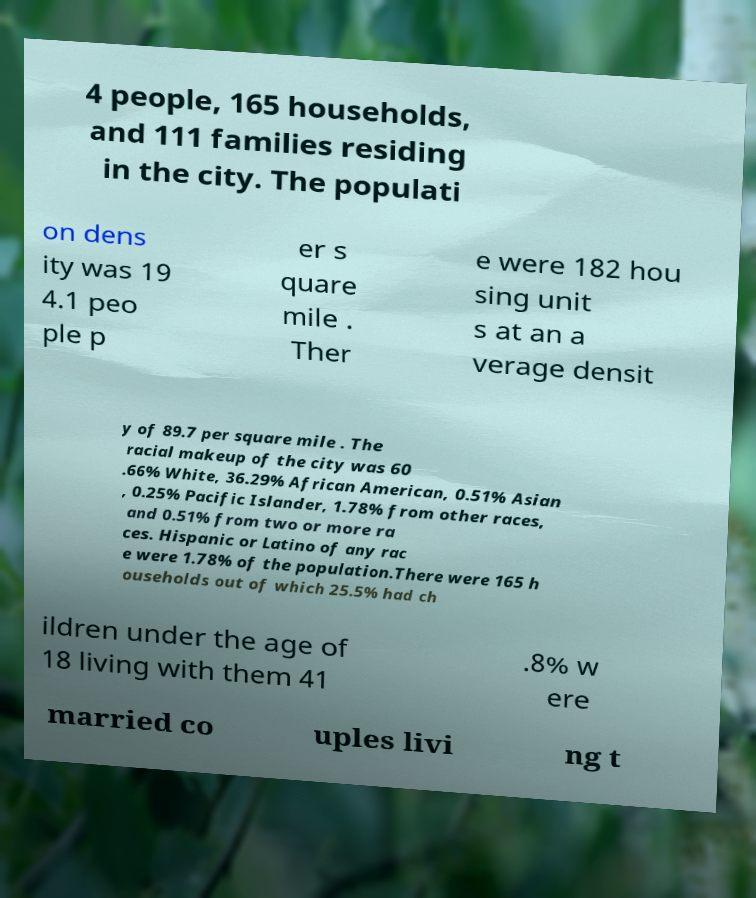Please read and relay the text visible in this image. What does it say? 4 people, 165 households, and 111 families residing in the city. The populati on dens ity was 19 4.1 peo ple p er s quare mile . Ther e were 182 hou sing unit s at an a verage densit y of 89.7 per square mile . The racial makeup of the city was 60 .66% White, 36.29% African American, 0.51% Asian , 0.25% Pacific Islander, 1.78% from other races, and 0.51% from two or more ra ces. Hispanic or Latino of any rac e were 1.78% of the population.There were 165 h ouseholds out of which 25.5% had ch ildren under the age of 18 living with them 41 .8% w ere married co uples livi ng t 